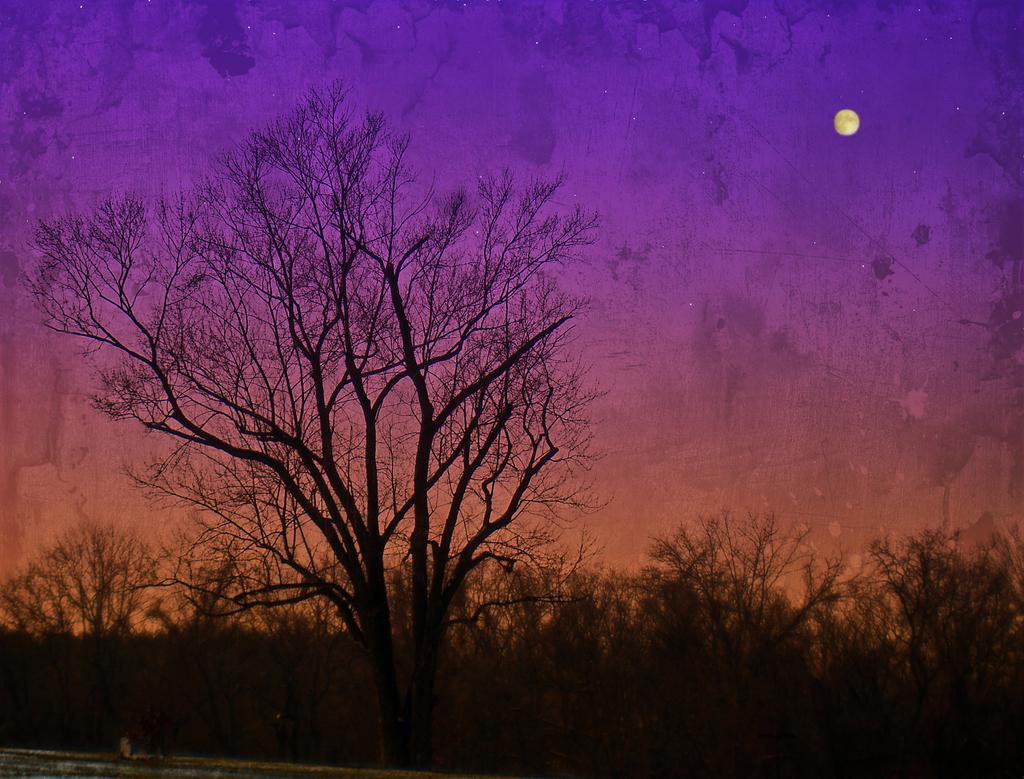How would you summarize this image in a sentence or two? There are dry trees and moon is present in the sky. 